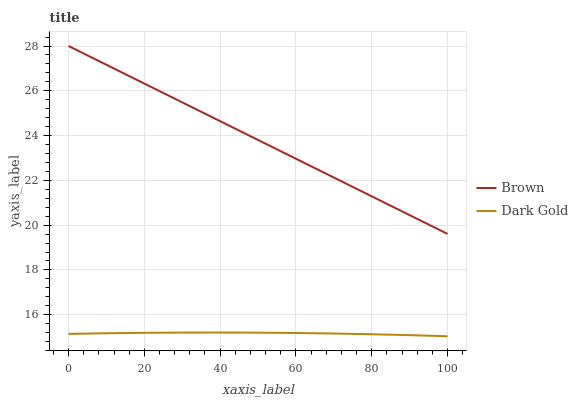Does Dark Gold have the minimum area under the curve?
Answer yes or no. Yes. Does Brown have the maximum area under the curve?
Answer yes or no. Yes. Does Dark Gold have the maximum area under the curve?
Answer yes or no. No. Is Brown the smoothest?
Answer yes or no. Yes. Is Dark Gold the roughest?
Answer yes or no. Yes. Is Dark Gold the smoothest?
Answer yes or no. No. Does Dark Gold have the lowest value?
Answer yes or no. Yes. Does Brown have the highest value?
Answer yes or no. Yes. Does Dark Gold have the highest value?
Answer yes or no. No. Is Dark Gold less than Brown?
Answer yes or no. Yes. Is Brown greater than Dark Gold?
Answer yes or no. Yes. Does Dark Gold intersect Brown?
Answer yes or no. No. 